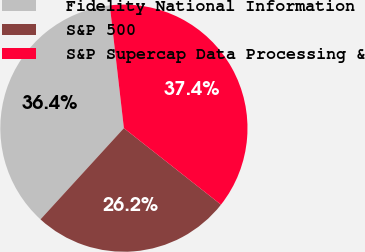Convert chart. <chart><loc_0><loc_0><loc_500><loc_500><pie_chart><fcel>Fidelity National Information<fcel>S&P 500<fcel>S&P Supercap Data Processing &<nl><fcel>36.39%<fcel>26.17%<fcel>37.44%<nl></chart> 